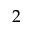Convert formula to latex. <formula><loc_0><loc_0><loc_500><loc_500>2</formula> 